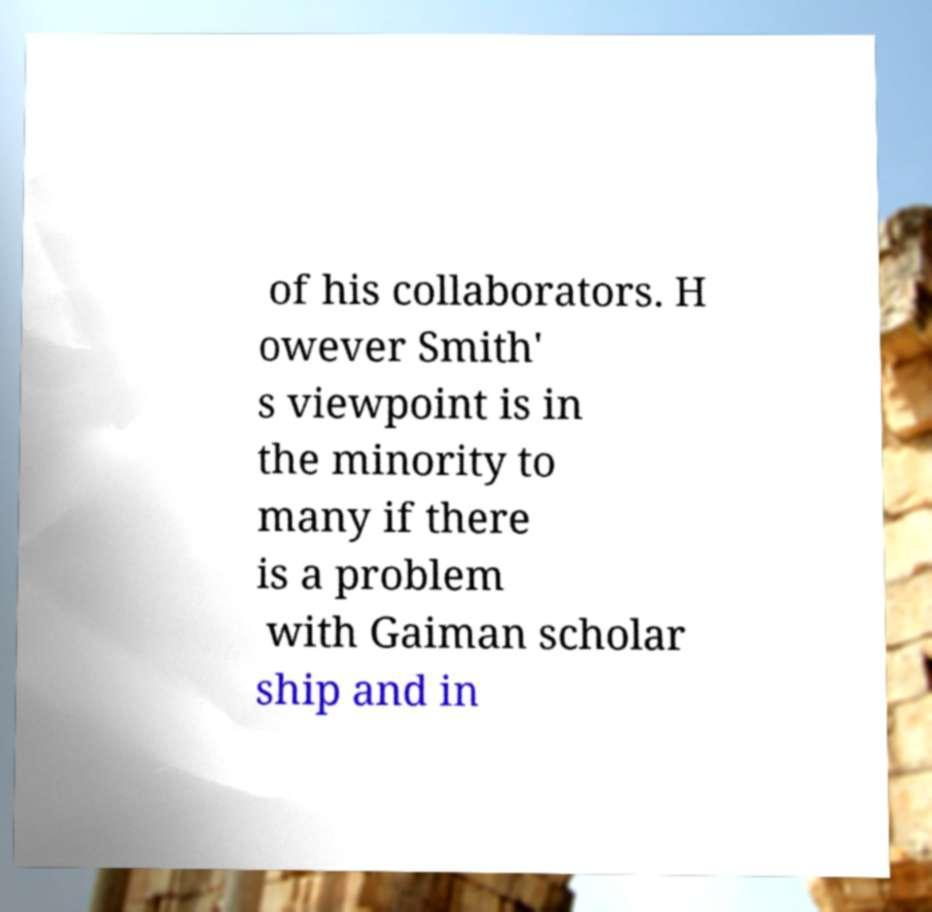Can you accurately transcribe the text from the provided image for me? of his collaborators. H owever Smith' s viewpoint is in the minority to many if there is a problem with Gaiman scholar ship and in 